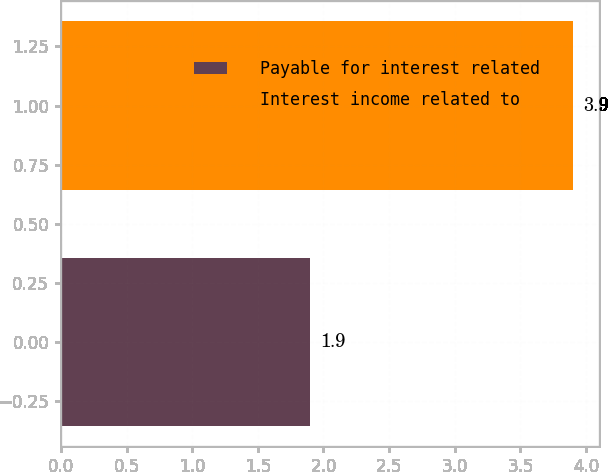Convert chart. <chart><loc_0><loc_0><loc_500><loc_500><bar_chart><fcel>Payable for interest related<fcel>Interest income related to<nl><fcel>1.9<fcel>3.9<nl></chart> 